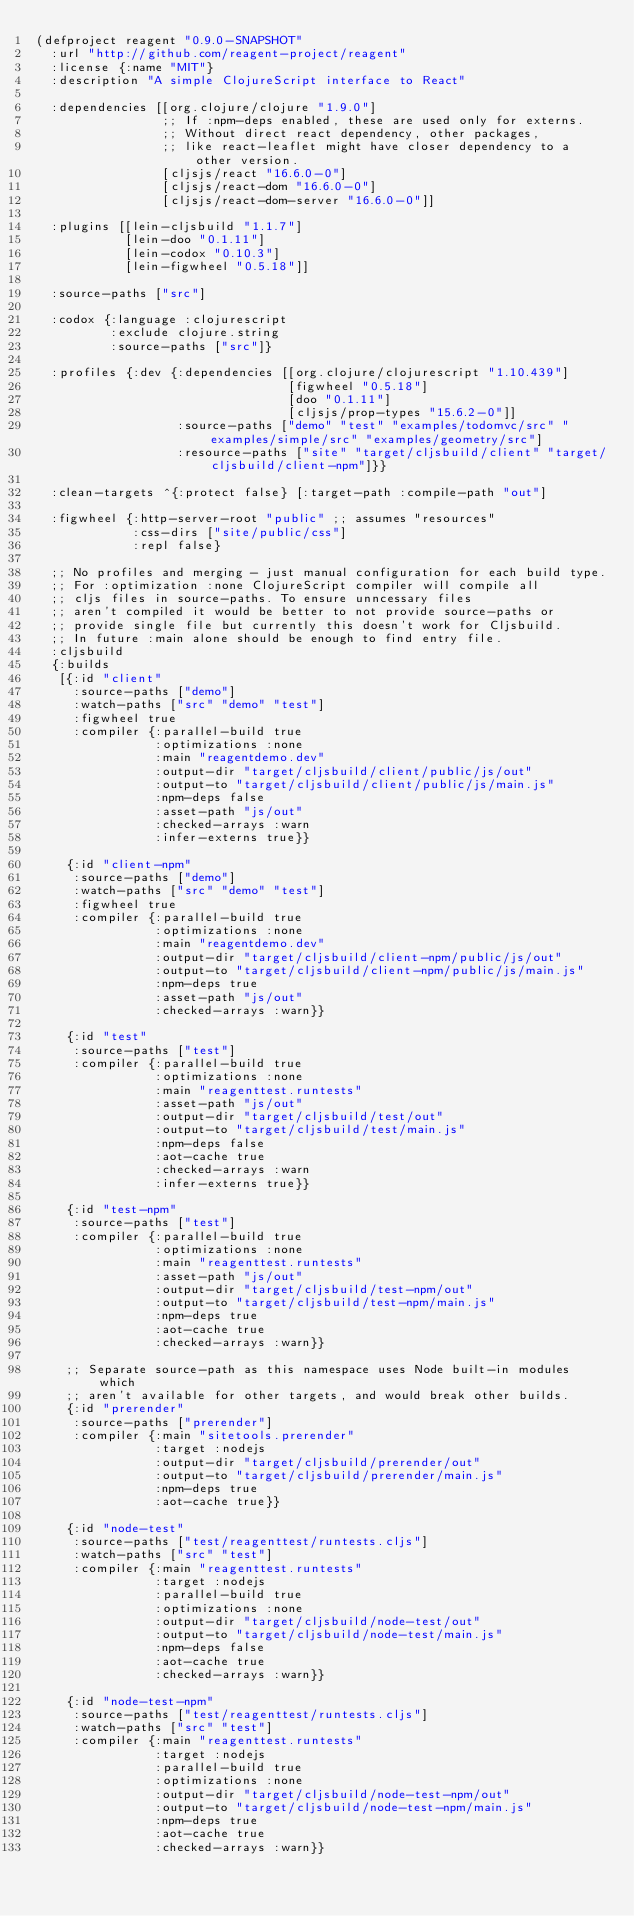<code> <loc_0><loc_0><loc_500><loc_500><_Clojure_>(defproject reagent "0.9.0-SNAPSHOT"
  :url "http://github.com/reagent-project/reagent"
  :license {:name "MIT"}
  :description "A simple ClojureScript interface to React"

  :dependencies [[org.clojure/clojure "1.9.0"]
                 ;; If :npm-deps enabled, these are used only for externs.
                 ;; Without direct react dependency, other packages,
                 ;; like react-leaflet might have closer dependency to a other version.
                 [cljsjs/react "16.6.0-0"]
                 [cljsjs/react-dom "16.6.0-0"]
                 [cljsjs/react-dom-server "16.6.0-0"]]

  :plugins [[lein-cljsbuild "1.1.7"]
            [lein-doo "0.1.11"]
            [lein-codox "0.10.3"]
            [lein-figwheel "0.5.18"]]

  :source-paths ["src"]

  :codox {:language :clojurescript
          :exclude clojure.string
          :source-paths ["src"]}

  :profiles {:dev {:dependencies [[org.clojure/clojurescript "1.10.439"]
                                  [figwheel "0.5.18"]
                                  [doo "0.1.11"]
                                  [cljsjs/prop-types "15.6.2-0"]]
                   :source-paths ["demo" "test" "examples/todomvc/src" "examples/simple/src" "examples/geometry/src"]
                   :resource-paths ["site" "target/cljsbuild/client" "target/cljsbuild/client-npm"]}}

  :clean-targets ^{:protect false} [:target-path :compile-path "out"]

  :figwheel {:http-server-root "public" ;; assumes "resources"
             :css-dirs ["site/public/css"]
             :repl false}

  ;; No profiles and merging - just manual configuration for each build type.
  ;; For :optimization :none ClojureScript compiler will compile all
  ;; cljs files in source-paths. To ensure unncessary files
  ;; aren't compiled it would be better to not provide source-paths or
  ;; provide single file but currently this doesn't work for Cljsbuild.
  ;; In future :main alone should be enough to find entry file.
  :cljsbuild
  {:builds
   [{:id "client"
     :source-paths ["demo"]
     :watch-paths ["src" "demo" "test"]
     :figwheel true
     :compiler {:parallel-build true
                :optimizations :none
                :main "reagentdemo.dev"
                :output-dir "target/cljsbuild/client/public/js/out"
                :output-to "target/cljsbuild/client/public/js/main.js"
                :npm-deps false
                :asset-path "js/out"
                :checked-arrays :warn
                :infer-externs true}}

    {:id "client-npm"
     :source-paths ["demo"]
     :watch-paths ["src" "demo" "test"]
     :figwheel true
     :compiler {:parallel-build true
                :optimizations :none
                :main "reagentdemo.dev"
                :output-dir "target/cljsbuild/client-npm/public/js/out"
                :output-to "target/cljsbuild/client-npm/public/js/main.js"
                :npm-deps true
                :asset-path "js/out"
                :checked-arrays :warn}}

    {:id "test"
     :source-paths ["test"]
     :compiler {:parallel-build true
                :optimizations :none
                :main "reagenttest.runtests"
                :asset-path "js/out"
                :output-dir "target/cljsbuild/test/out"
                :output-to "target/cljsbuild/test/main.js"
                :npm-deps false
                :aot-cache true
                :checked-arrays :warn
                :infer-externs true}}

    {:id "test-npm"
     :source-paths ["test"]
     :compiler {:parallel-build true
                :optimizations :none
                :main "reagenttest.runtests"
                :asset-path "js/out"
                :output-dir "target/cljsbuild/test-npm/out"
                :output-to "target/cljsbuild/test-npm/main.js"
                :npm-deps true
                :aot-cache true
                :checked-arrays :warn}}

    ;; Separate source-path as this namespace uses Node built-in modules which
    ;; aren't available for other targets, and would break other builds.
    {:id "prerender"
     :source-paths ["prerender"]
     :compiler {:main "sitetools.prerender"
                :target :nodejs
                :output-dir "target/cljsbuild/prerender/out"
                :output-to "target/cljsbuild/prerender/main.js"
                :npm-deps true
                :aot-cache true}}

    {:id "node-test"
     :source-paths ["test/reagenttest/runtests.cljs"]
     :watch-paths ["src" "test"]
     :compiler {:main "reagenttest.runtests"
                :target :nodejs
                :parallel-build true
                :optimizations :none
                :output-dir "target/cljsbuild/node-test/out"
                :output-to "target/cljsbuild/node-test/main.js"
                :npm-deps false
                :aot-cache true
                :checked-arrays :warn}}

    {:id "node-test-npm"
     :source-paths ["test/reagenttest/runtests.cljs"]
     :watch-paths ["src" "test"]
     :compiler {:main "reagenttest.runtests"
                :target :nodejs
                :parallel-build true
                :optimizations :none
                :output-dir "target/cljsbuild/node-test-npm/out"
                :output-to "target/cljsbuild/node-test-npm/main.js"
                :npm-deps true
                :aot-cache true
                :checked-arrays :warn}}
</code> 